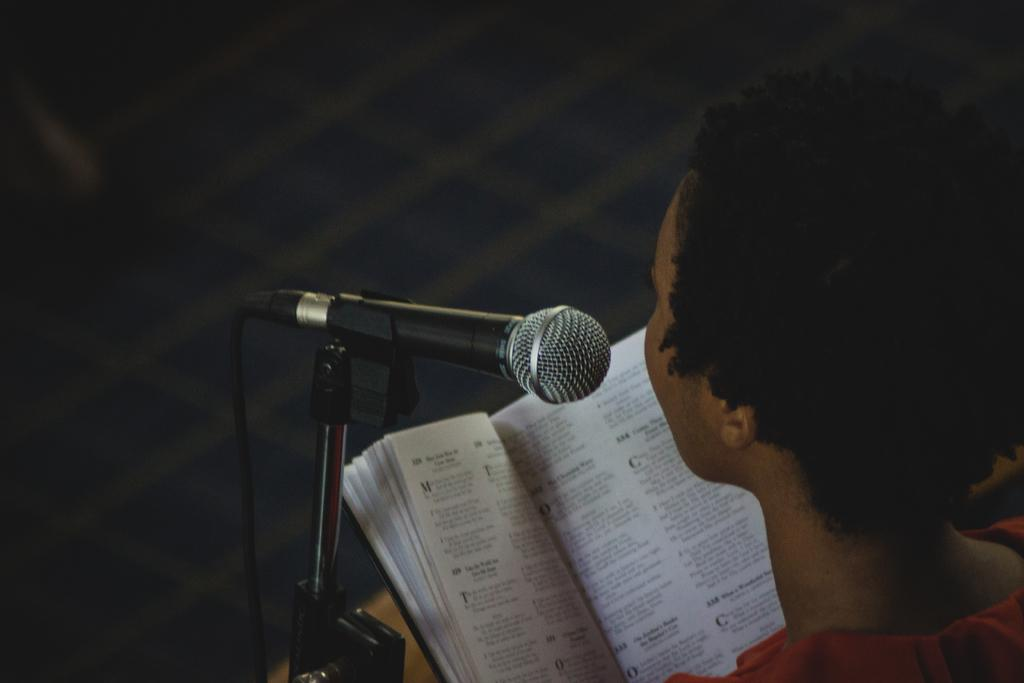Who or what is on the right side of the image? There is a person on the right side of the image. What is in front of the person? There is a mic and a book in front of the person. What type of disease is the person suffering from in the image? There is no indication of any disease in the image; it only shows a person with a mic and a book in front of them. 